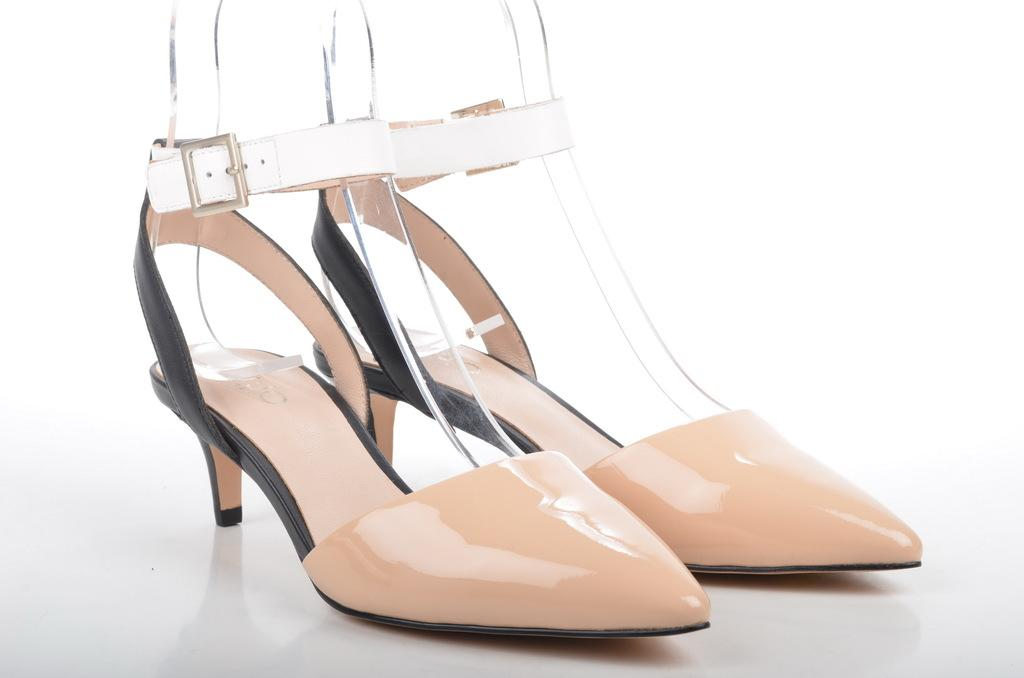What type of object can be seen in the image? There is footwear in the image. What type of coast can be seen in the image? There is no coast present in the image; it features footwear. What is the front of the footwear made of in the image? The image does not provide enough detail to determine the material of the front of the footwear. 